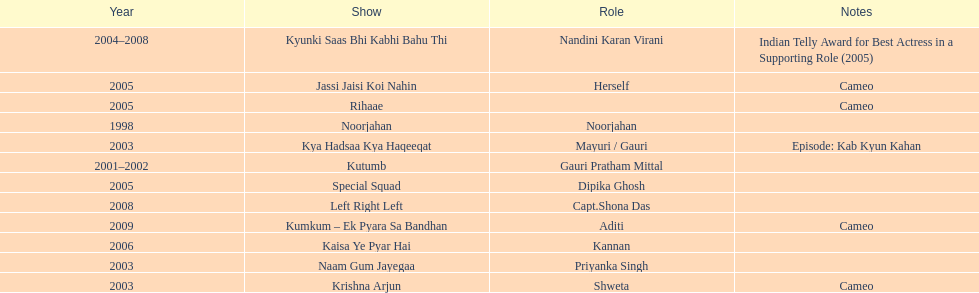The show above left right left Kaisa Ye Pyar Hai. 